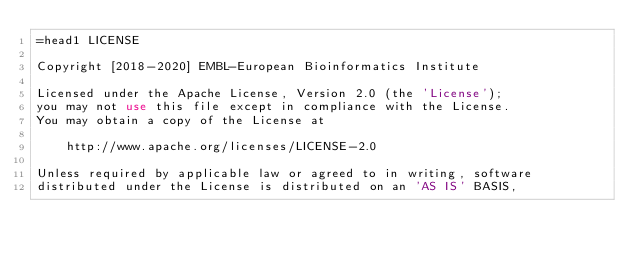Convert code to text. <code><loc_0><loc_0><loc_500><loc_500><_Perl_>=head1 LICENSE

Copyright [2018-2020] EMBL-European Bioinformatics Institute

Licensed under the Apache License, Version 2.0 (the 'License');
you may not use this file except in compliance with the License.
You may obtain a copy of the License at

    http://www.apache.org/licenses/LICENSE-2.0

Unless required by applicable law or agreed to in writing, software
distributed under the License is distributed on an 'AS IS' BASIS,</code> 